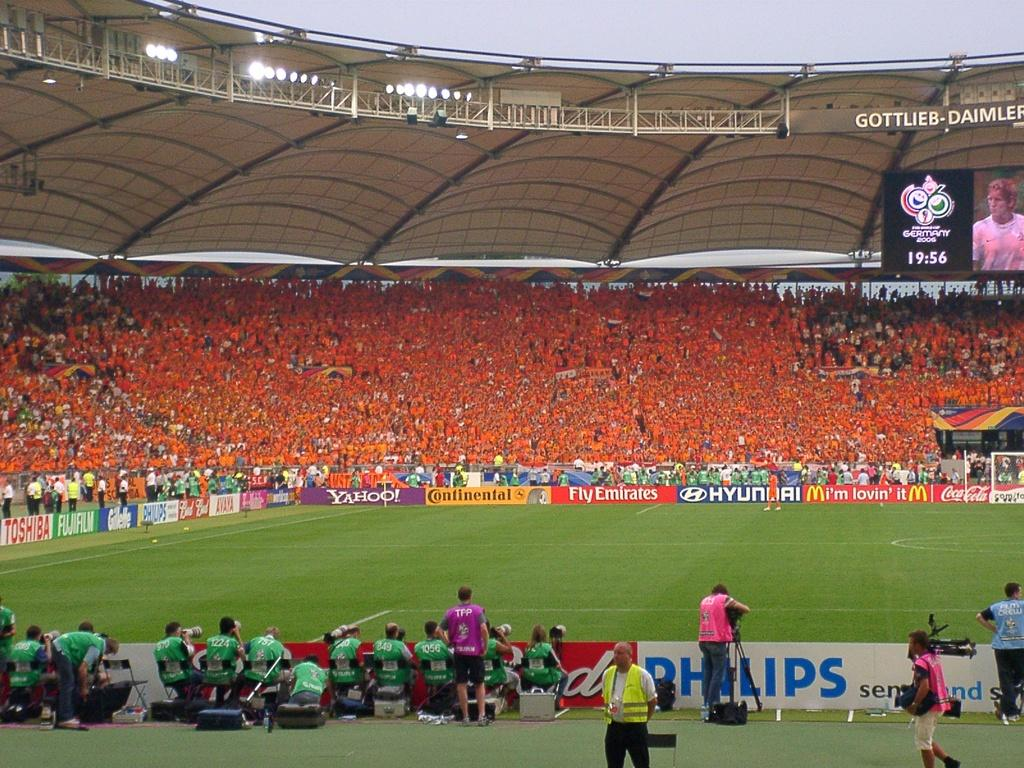<image>
Describe the image concisely. The Gottleib-Daimler football stadium is filled with people and there are many advertising signs around the field including Hyundai, Yahoo!, and Continental. 